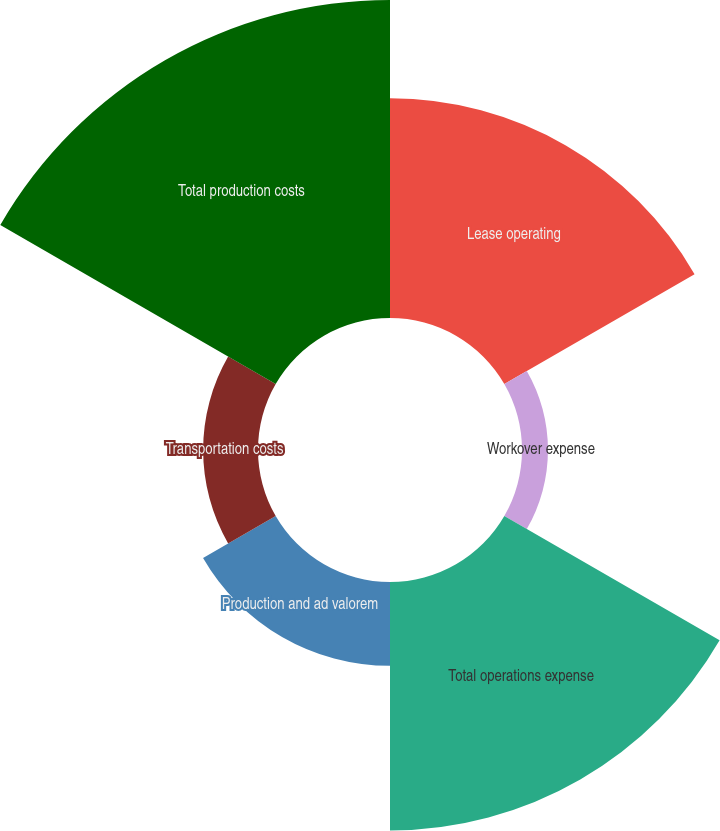Convert chart. <chart><loc_0><loc_0><loc_500><loc_500><pie_chart><fcel>Lease operating<fcel>Workover expense<fcel>Total operations expense<fcel>Production and ad valorem<fcel>Transportation costs<fcel>Total production costs<nl><fcel>23.1%<fcel>2.73%<fcel>26.14%<fcel>8.82%<fcel>5.77%<fcel>33.44%<nl></chart> 